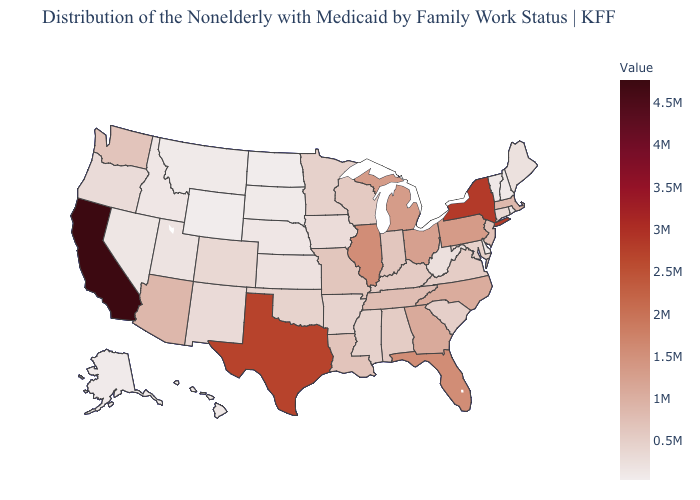Which states hav the highest value in the MidWest?
Quick response, please. Illinois. Does North Dakota have the lowest value in the MidWest?
Short answer required. Yes. Among the states that border Nevada , which have the highest value?
Concise answer only. California. Which states have the lowest value in the USA?
Concise answer only. North Dakota. 